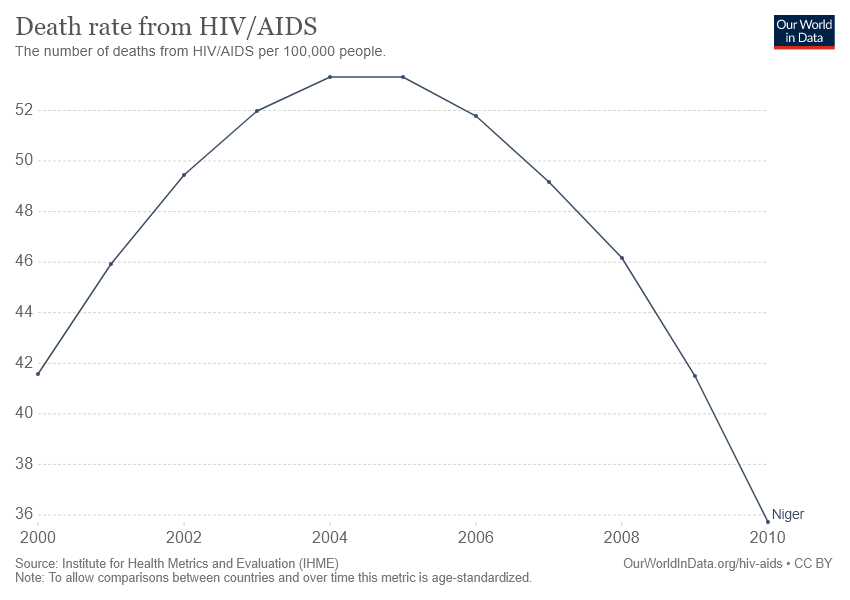Highlight a few significant elements in this photo. The difference between the highest and lowest number of death rates from HIV/AIDS is approximately 19 years. The number of deaths decreased between the years 2005 and 2010. 